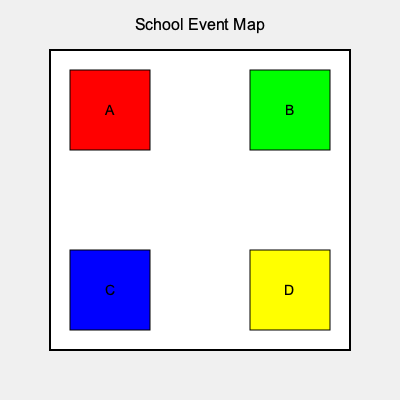Based on the color-coded map of the school grounds, which station should be assigned for the face painting activity if red represents high foot traffic areas, green represents quiet zones, blue represents water-based activities, and yellow represents food areas? To determine the best station for face painting, let's analyze each color-coded area:

1. Red (Station A): High foot traffic areas
   - Not ideal for face painting as it requires a calm environment

2. Green (Station B): Quiet zones
   - Perfect for face painting as it needs a calm, less crowded area

3. Blue (Station C): Water-based activities
   - Not suitable for face painting as water can interfere with the paint

4. Yellow (Station D): Food areas
   - Not appropriate for face painting due to hygiene concerns

Face painting requires a calm environment away from water and food. The green area (Station B) representing quiet zones is the most suitable location for this activity.
Answer: Station B 